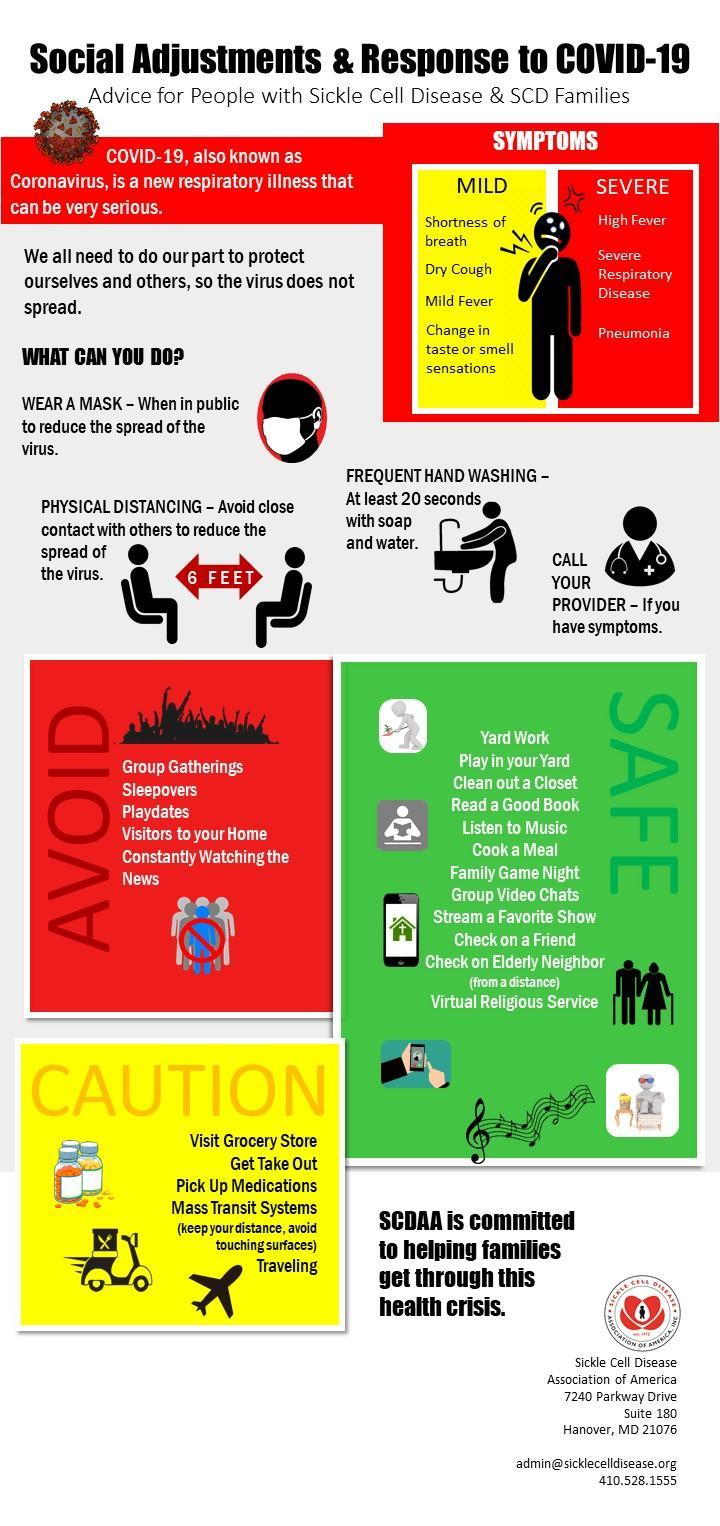What is the precautionary measure to be taken other than physical distancing & frequent hand washing to avoid the spread of coronavirus?
Answer the question with a short phrase. WEAR A MASK What is the safe distance to be maintained with one another to avoid the spread of COVID-19? 6 F E E T What is the severe symptom of COVID-19 other than high fever & Pneumonia? Severe Respiratory Disease 